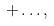Convert formula to latex. <formula><loc_0><loc_0><loc_500><loc_500>+ \dots , \\</formula> 